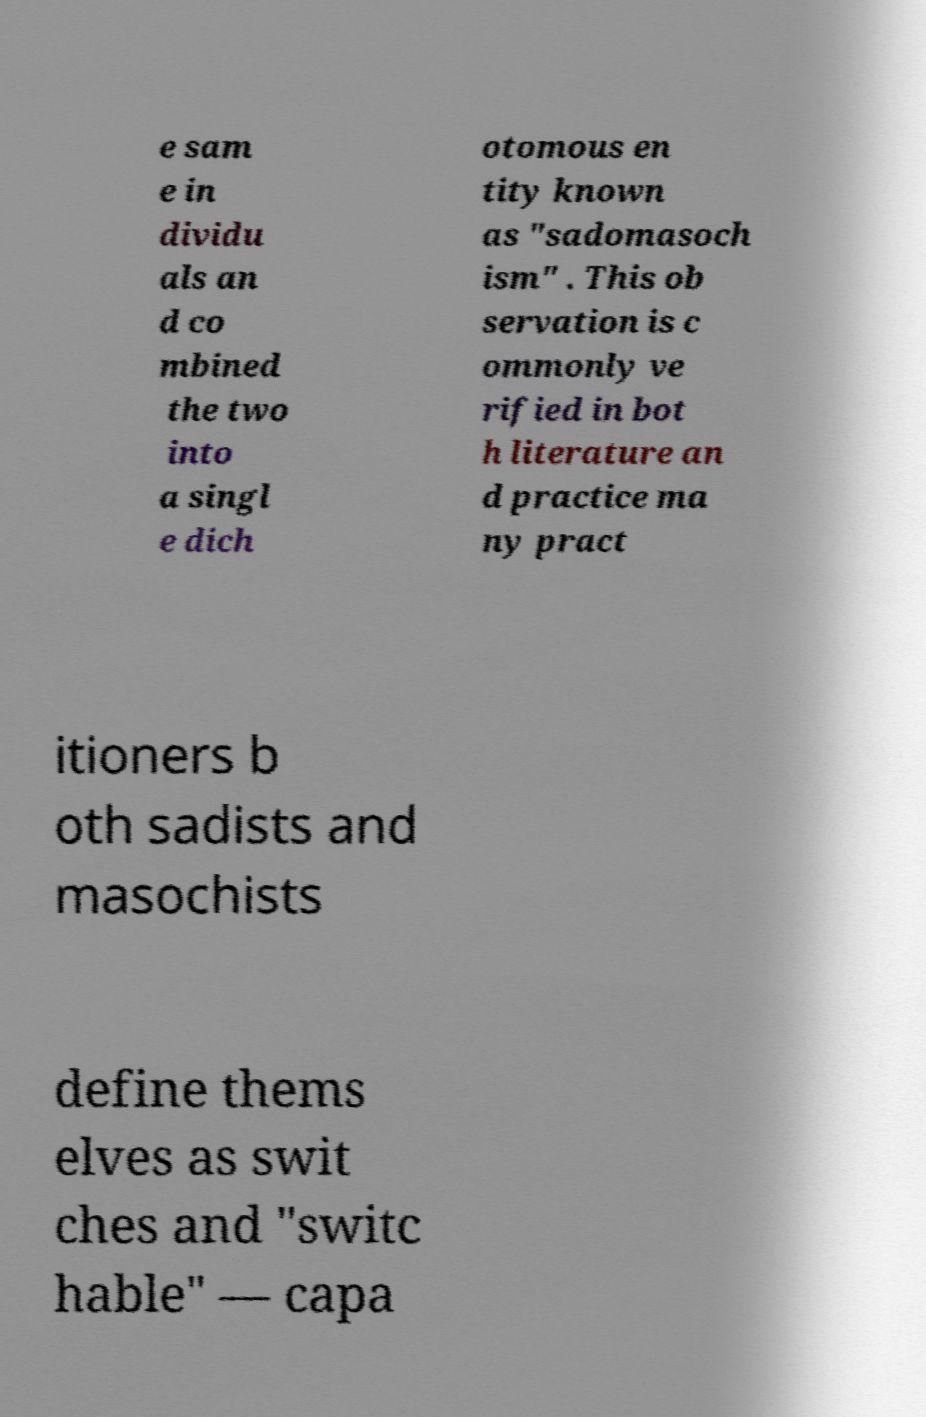There's text embedded in this image that I need extracted. Can you transcribe it verbatim? e sam e in dividu als an d co mbined the two into a singl e dich otomous en tity known as "sadomasoch ism" . This ob servation is c ommonly ve rified in bot h literature an d practice ma ny pract itioners b oth sadists and masochists define thems elves as swit ches and "switc hable" — capa 